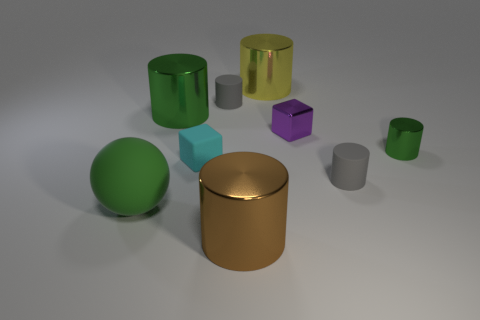Subtract all gray blocks. How many green cylinders are left? 2 Subtract all big green metal cylinders. How many cylinders are left? 5 Add 1 small purple metal cubes. How many objects exist? 10 Subtract all green cylinders. How many cylinders are left? 4 Subtract 1 blocks. How many blocks are left? 1 Subtract all blocks. How many objects are left? 7 Add 3 matte cubes. How many matte cubes are left? 4 Add 5 green cubes. How many green cubes exist? 5 Subtract 0 yellow balls. How many objects are left? 9 Subtract all yellow spheres. Subtract all brown cubes. How many spheres are left? 1 